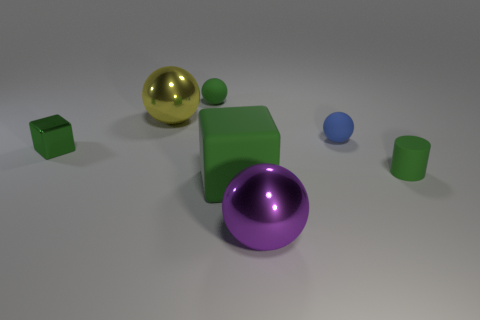Subtract all large purple balls. How many balls are left? 3 Subtract all green spheres. How many spheres are left? 3 Add 1 red shiny spheres. How many objects exist? 8 Subtract all yellow spheres. Subtract all cyan cubes. How many spheres are left? 3 Subtract all balls. How many objects are left? 3 Subtract 0 brown cubes. How many objects are left? 7 Subtract all red rubber spheres. Subtract all metal objects. How many objects are left? 4 Add 4 blue rubber balls. How many blue rubber balls are left? 5 Add 3 matte cylinders. How many matte cylinders exist? 4 